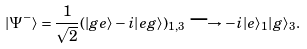<formula> <loc_0><loc_0><loc_500><loc_500>| \Psi ^ { - } \rangle = \frac { 1 } { \sqrt { 2 } } ( | g e \rangle - i | e g \rangle ) _ { 1 , 3 } \longrightarrow - i | e \rangle _ { 1 } | g \rangle _ { 3 } .</formula> 